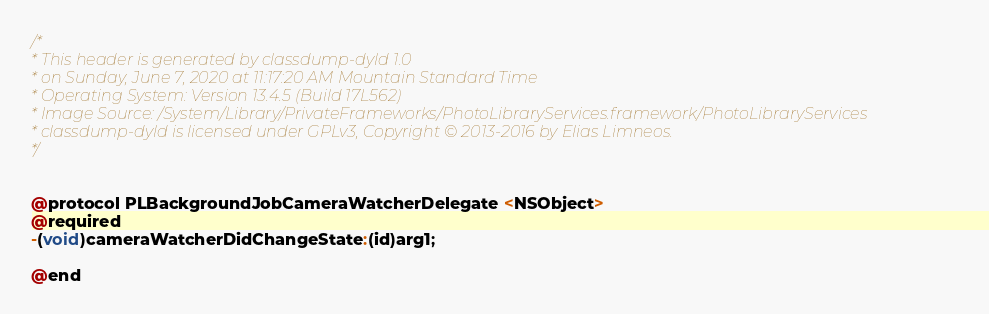<code> <loc_0><loc_0><loc_500><loc_500><_C_>/*
* This header is generated by classdump-dyld 1.0
* on Sunday, June 7, 2020 at 11:17:20 AM Mountain Standard Time
* Operating System: Version 13.4.5 (Build 17L562)
* Image Source: /System/Library/PrivateFrameworks/PhotoLibraryServices.framework/PhotoLibraryServices
* classdump-dyld is licensed under GPLv3, Copyright © 2013-2016 by Elias Limneos.
*/


@protocol PLBackgroundJobCameraWatcherDelegate <NSObject>
@required
-(void)cameraWatcherDidChangeState:(id)arg1;

@end

</code> 